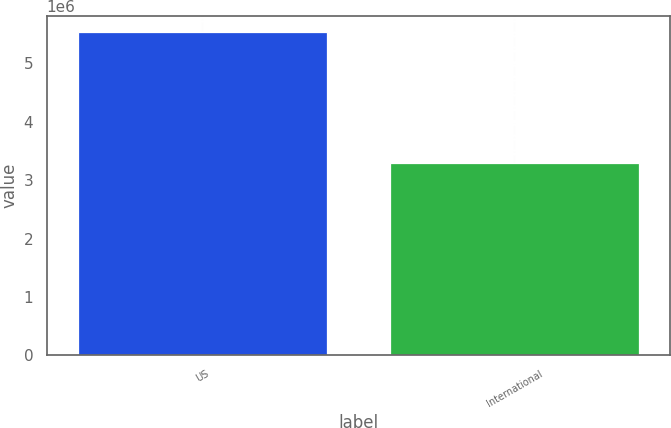Convert chart to OTSL. <chart><loc_0><loc_0><loc_500><loc_500><bar_chart><fcel>US<fcel>International<nl><fcel>5.534e+06<fcel>3.286e+06<nl></chart> 